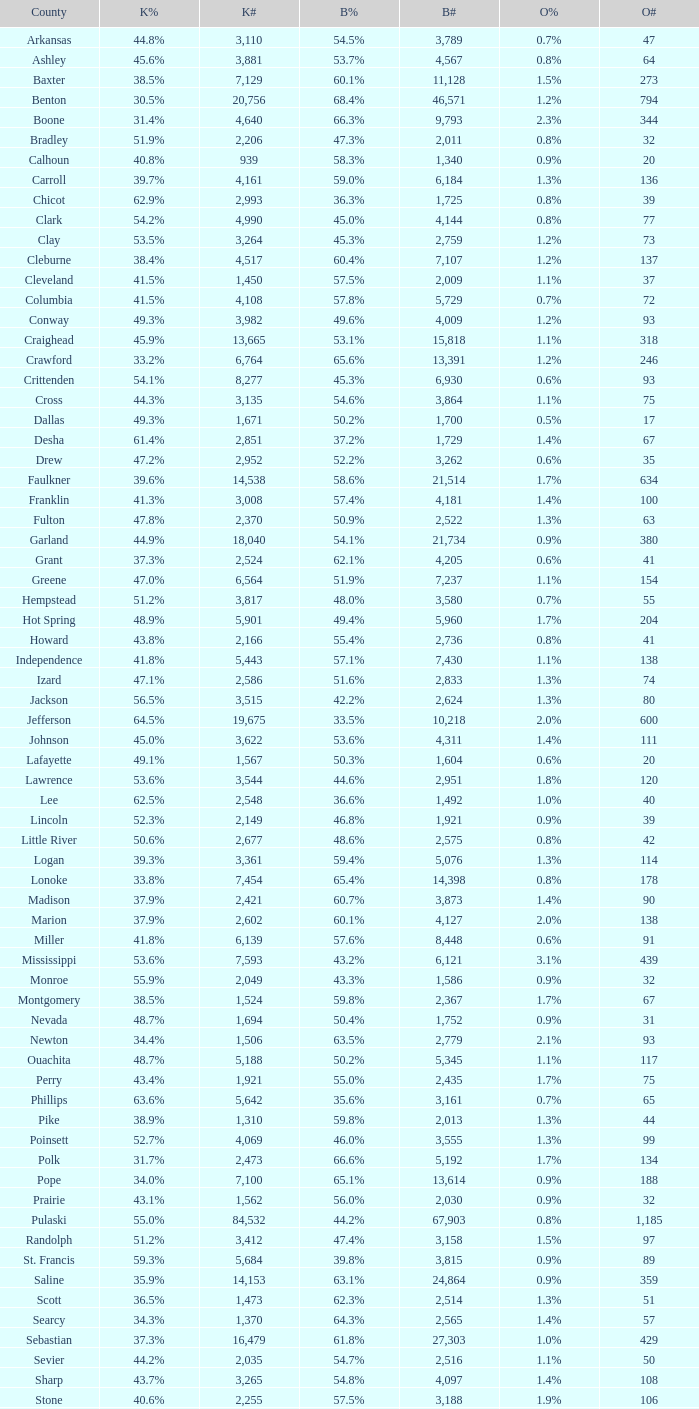What is the lowest Bush#, when Bush% is "65.4%"? 14398.0. 